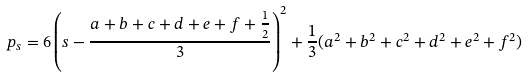<formula> <loc_0><loc_0><loc_500><loc_500>p _ { s } = 6 \left ( s - \frac { a + b + c + d + e + f + \frac { 1 } { 2 } } { 3 } \right ) ^ { 2 } + \frac { 1 } { 3 } ( a ^ { 2 } + b ^ { 2 } + c ^ { 2 } + d ^ { 2 } + e ^ { 2 } + f ^ { 2 } )</formula> 